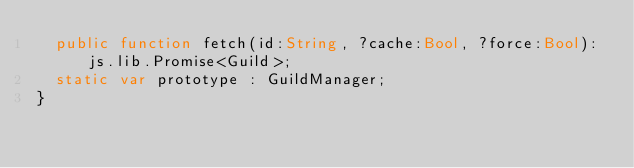<code> <loc_0><loc_0><loc_500><loc_500><_Haxe_>	public function fetch(id:String, ?cache:Bool, ?force:Bool):js.lib.Promise<Guild>;
	static var prototype : GuildManager;
}</code> 